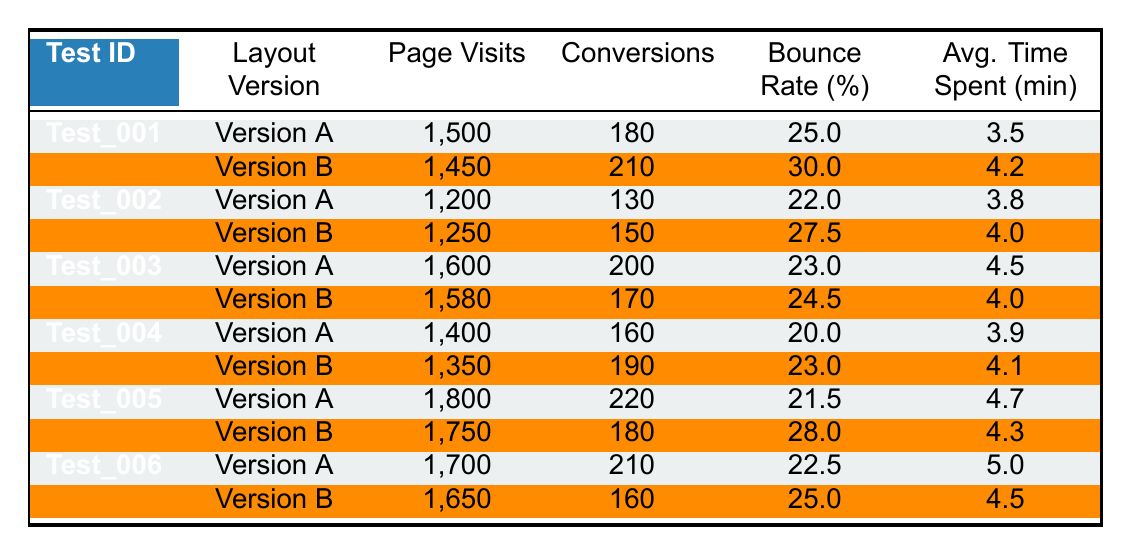What is the conversion rate for Version A of Test 001? The conversion rate is calculated by dividing the number of conversions by the total page visits and multiplying by 100. For Version A of Test 001, the number of conversions is 180 and page visits are 1500. Thus, the conversion rate is (180/1500) * 100 = 12%.
Answer: 12% Which layout version had a higher bounce rate in Test 003? To answer this, we need to check the bounce rates for both versions of Test 003. Version A has a bounce rate of 23.0% and Version B has a bounce rate of 24.5%. Since 24.5% is greater than 23.0%, Version B had a higher bounce rate.
Answer: Version B What is the average page visits for all Version A tests? The page visits for Version A are: 1500, 1200, 1600, 1400, 1800, and 1700. Sum these values: 1500 + 1200 + 1600 + 1400 + 1800 + 1700 = 10200. Now divide by the number of tests (6): 10200 / 6 = 1700.
Answer: 1700 What is the conversion difference between Version A and Version B for Test 005? For Test 005, the conversions for Version A are 220 and for Version B are 180. The difference is calculated as 220 - 180 = 40.
Answer: 40 Did Version B of Test 002 achieve more conversions compared to its Version A? In Test 002, Version A had 130 conversions and Version B had 150 conversions. Since 150 is greater than 130, the answer is yes.
Answer: Yes What is the total bounce rate for all Version B tests? The bounce rates for Version B tests are: 30.0, 27.5, 24.5, 23.0, 28.0, and 25.0. Summing these values gives: 30.0 + 27.5 + 24.5 + 23.0 + 28.0 + 25.0 = 158.0. There are 6 tests, so we then divide to find the average: 158.0 / 6 = 26.33.
Answer: 26.33 Which layout version performed better in terms of average time spent for all tests? The times spent for Version A are: 3.5, 3.8, 4.5, 3.9, 4.7, and 5.0, totaling to 25.4. For Version B, the times are 4.2, 4.0, 4.0, 4.1, 4.3, and 4.5, totaling to 24.1. The average for Version A is 25.4 / 6 = 4.23 and for Version B is 24.1 / 6 = 4.02. Since 4.23 is greater than 4.02, Version A performed better.
Answer: Version A How many total conversions were recorded for Test 004? For Test 004, the conversions were 160 for Version A and 190 for Version B. The total conversions are calculated as 160 + 190 = 350.
Answer: 350 What percentage of page visits led to conversions for Version A of Test 006? For Version A of Test 006, the page visits are 1700 and conversions are 210. The percentage is found by (210/1700) * 100 = 12.35%.
Answer: 12.35% Which test had the highest total number of page visits across both versions? Calculating total page visits for each test: Test 001: 1500 + 1450 = 2950; Test 002: 1200 + 1250 = 2450; Test 003: 1600 + 1580 = 3180; Test 004: 1400 + 1350 = 2750; Test 005: 1800 + 1750 = 3550; Test 006: 1700 + 1650 = 3350. The highest total is 3550 for Test 005.
Answer: Test 005 What was the average bounce rate across all tests for Version A? The bounce rates for Version A are: 25.0, 22.0, 23.0, 20.0, 21.5, and 22.5. The total is 25 + 22 + 23 + 20 + 21.5 + 22.5 = 134. The average is 134 / 6 = 22.33.
Answer: 22.33 